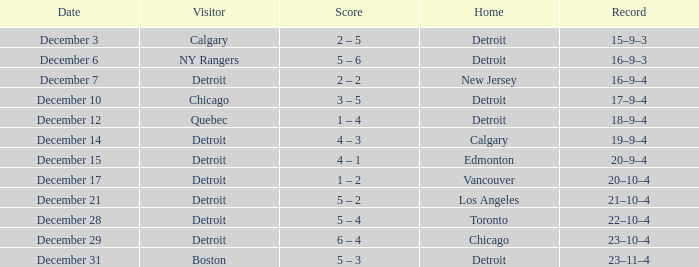What is the date for the home detroit and visitor was chicago? December 10. 